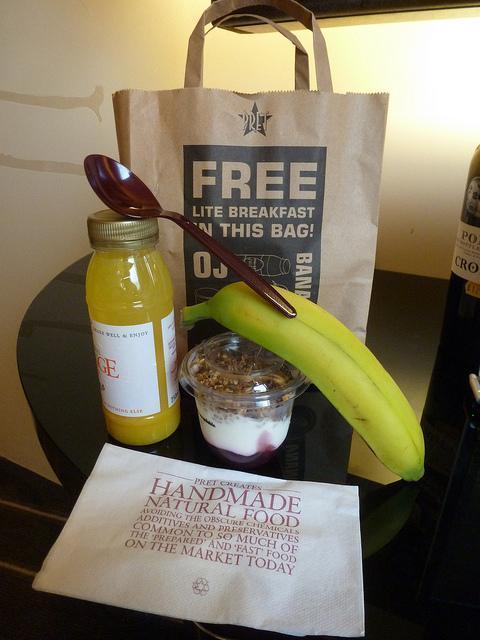What liquid have they been given for breakfast?
Select the correct answer and articulate reasoning with the following format: 'Answer: answer
Rationale: rationale.'
Options: Banana juice, mango juice, pineapple juice, orange juice. Answer: orange juice.
Rationale: There is oj in the jar. 